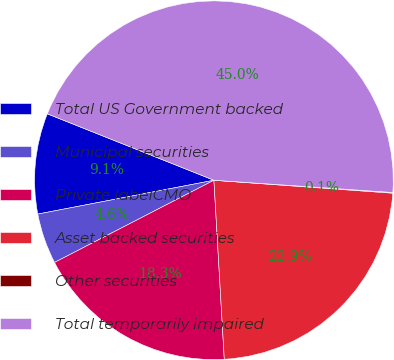<chart> <loc_0><loc_0><loc_500><loc_500><pie_chart><fcel>Total US Government backed<fcel>Municipal securities<fcel>Private labelCMO<fcel>Asset backed securities<fcel>Other securities<fcel>Total temporarily impaired<nl><fcel>9.06%<fcel>4.56%<fcel>18.34%<fcel>22.93%<fcel>0.06%<fcel>45.05%<nl></chart> 